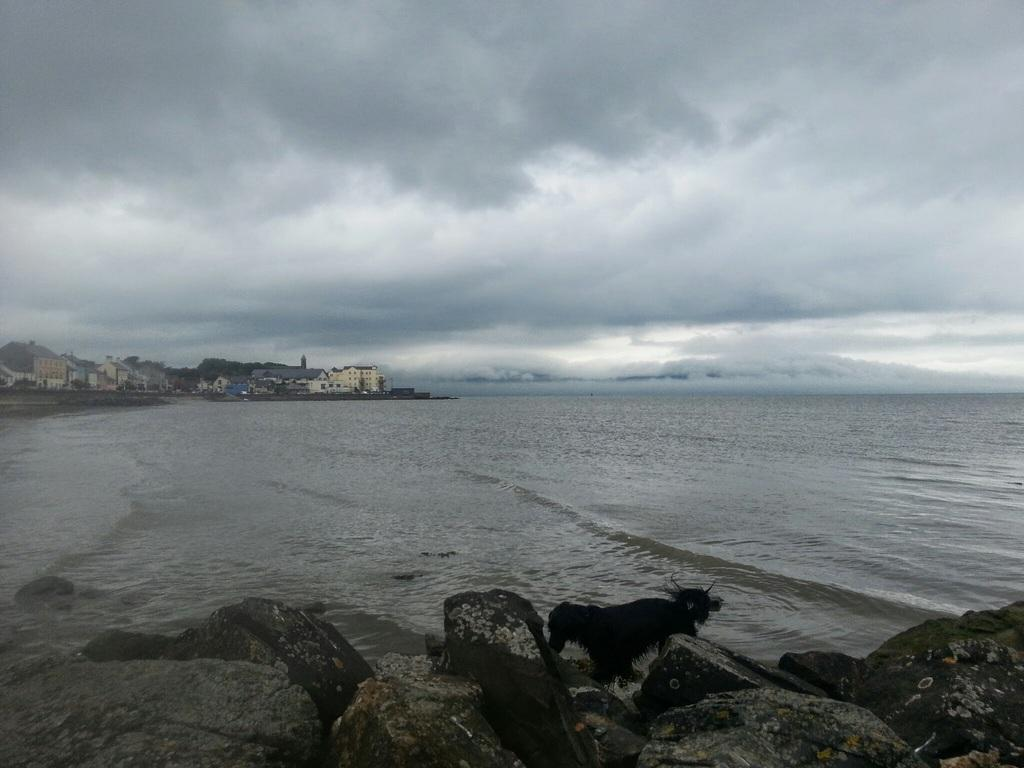What type of animal is in the image? There is an animal in the image, but its specific type cannot be determined from the provided facts. What color is the animal in the image? The animal is black in color. What other objects can be seen in the image? There are stones, buildings, and water visible in the image. What is the condition of the sky in the image? The sky is cloudy in the image. What type of steel is used to construct the buildings in the image? There is no information about the type of steel used in the construction of the buildings in the image. Can you tell me how many requests the animal in the image has made? There is no information about any requests made by the animal in the image. 